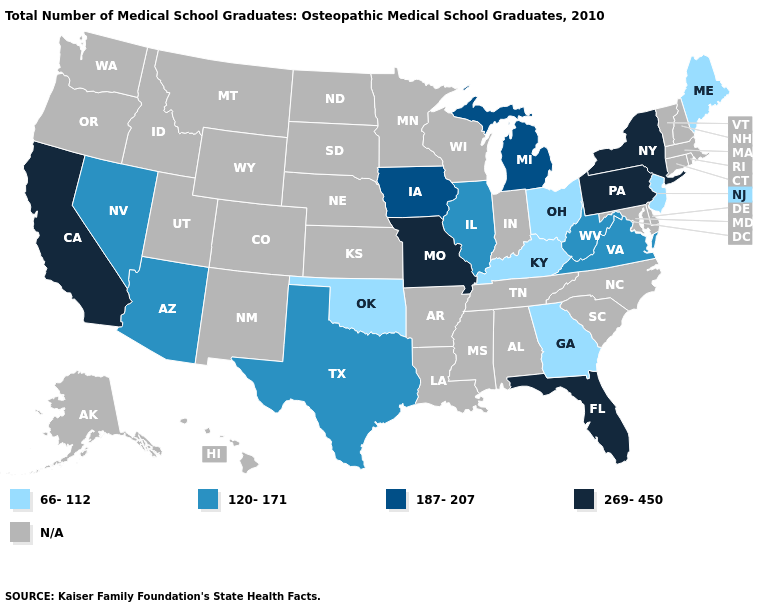What is the highest value in the Northeast ?
Write a very short answer. 269-450. What is the lowest value in the MidWest?
Short answer required. 66-112. Among the states that border Minnesota , which have the highest value?
Give a very brief answer. Iowa. Does the first symbol in the legend represent the smallest category?
Short answer required. Yes. Does the map have missing data?
Short answer required. Yes. Name the states that have a value in the range 269-450?
Concise answer only. California, Florida, Missouri, New York, Pennsylvania. Is the legend a continuous bar?
Short answer required. No. How many symbols are there in the legend?
Keep it brief. 5. Among the states that border Arkansas , does Missouri have the highest value?
Answer briefly. Yes. Which states have the highest value in the USA?
Quick response, please. California, Florida, Missouri, New York, Pennsylvania. Which states have the lowest value in the South?
Give a very brief answer. Georgia, Kentucky, Oklahoma. 